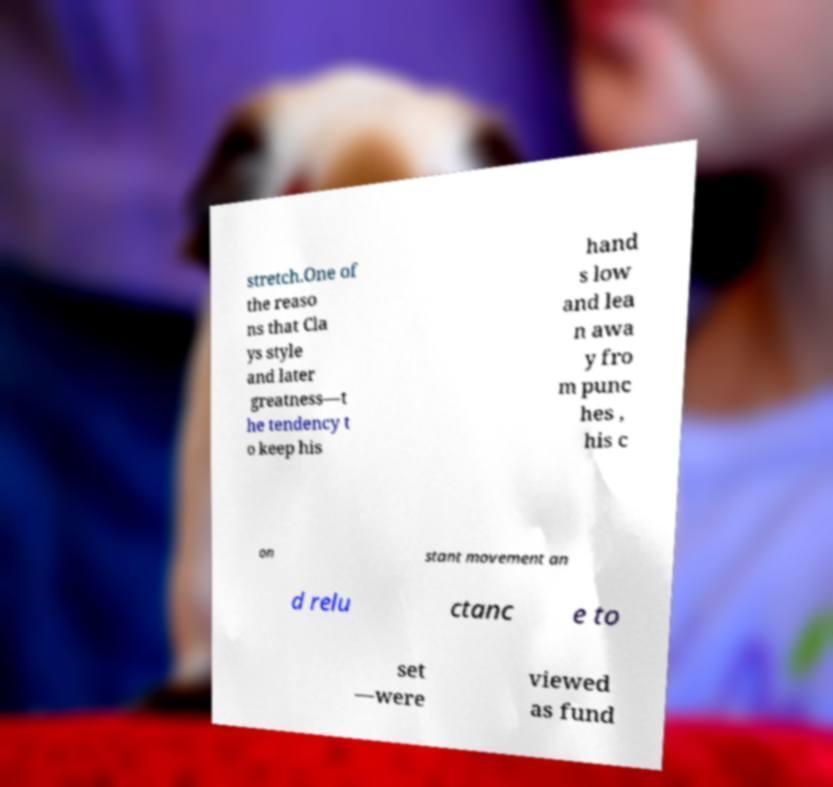Could you extract and type out the text from this image? stretch.One of the reaso ns that Cla ys style and later greatness—t he tendency t o keep his hand s low and lea n awa y fro m punc hes , his c on stant movement an d relu ctanc e to set —were viewed as fund 